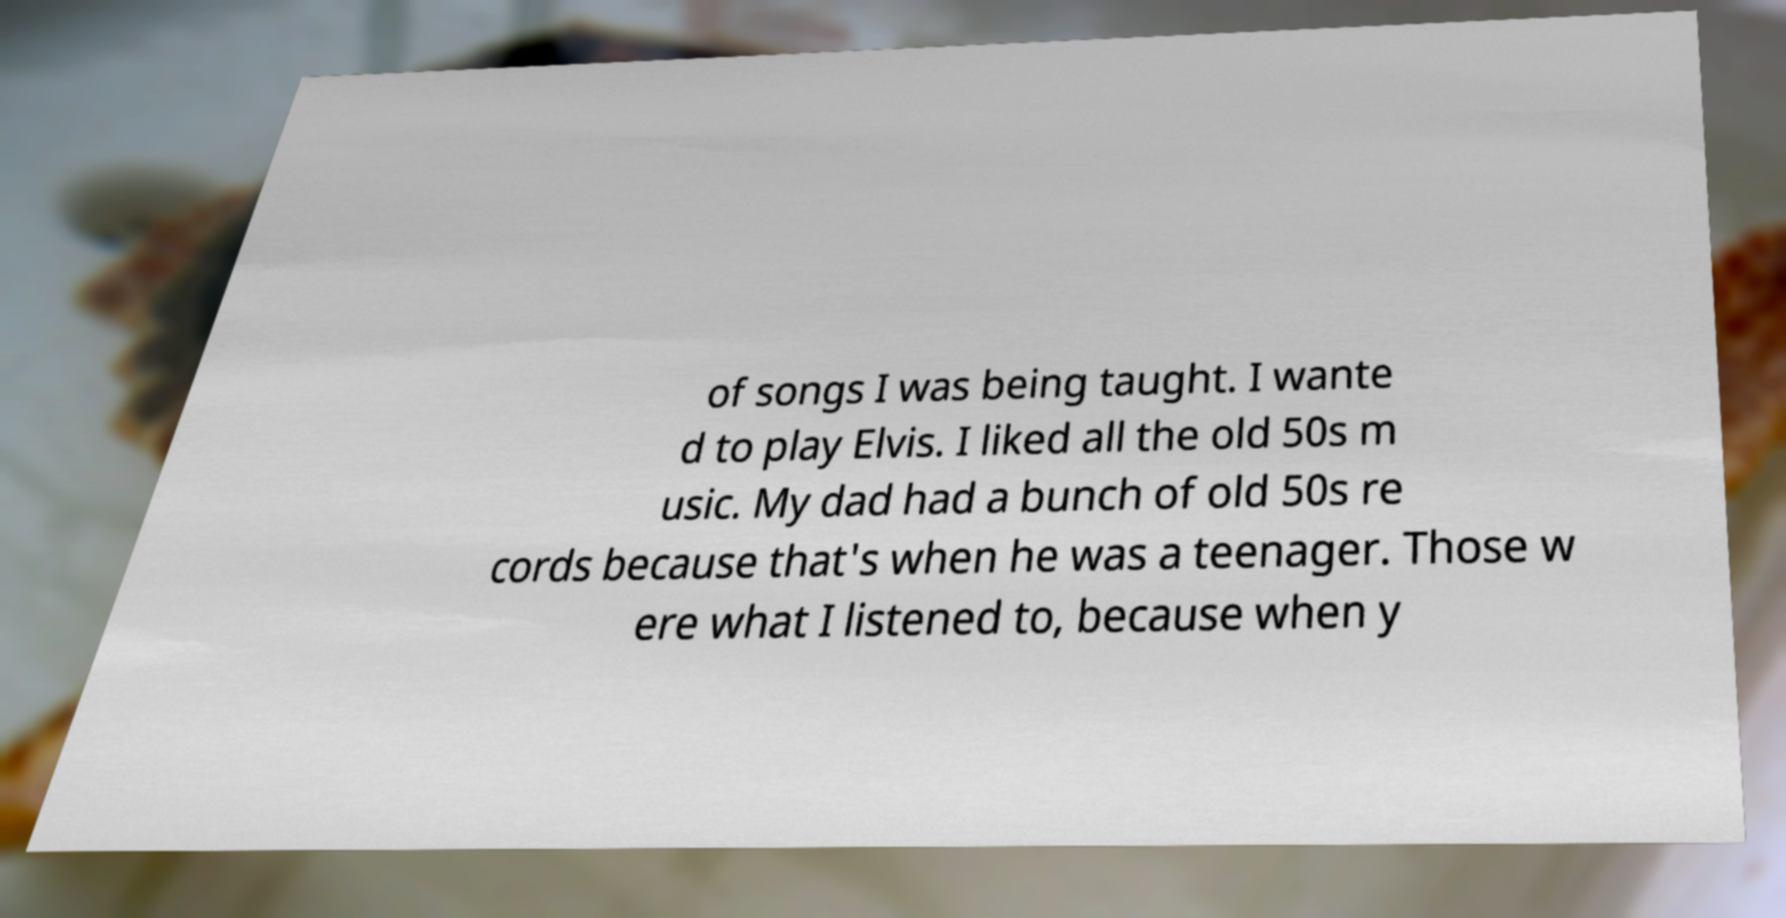Could you extract and type out the text from this image? of songs I was being taught. I wante d to play Elvis. I liked all the old 50s m usic. My dad had a bunch of old 50s re cords because that's when he was a teenager. Those w ere what I listened to, because when y 